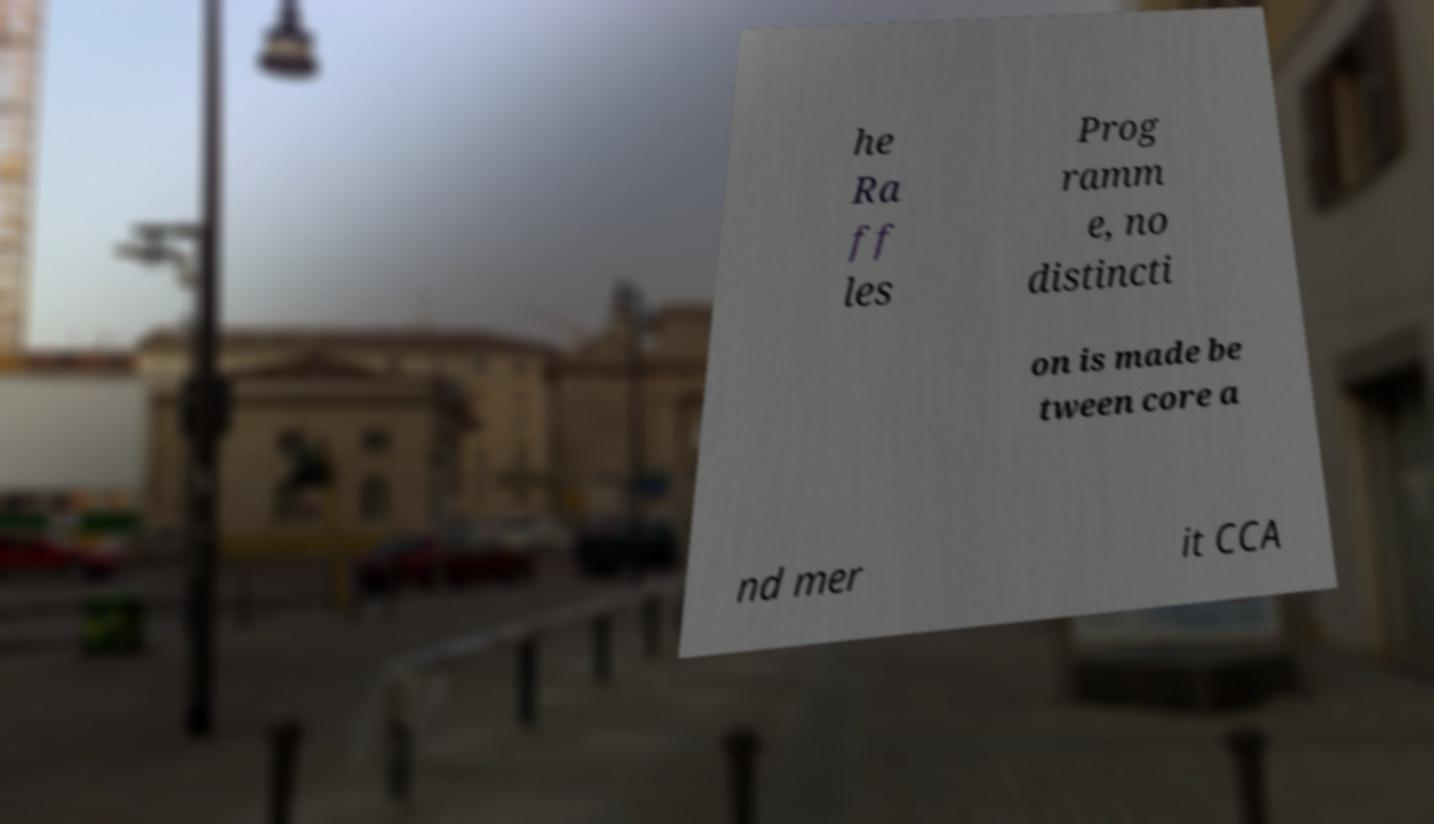Could you assist in decoding the text presented in this image and type it out clearly? he Ra ff les Prog ramm e, no distincti on is made be tween core a nd mer it CCA 